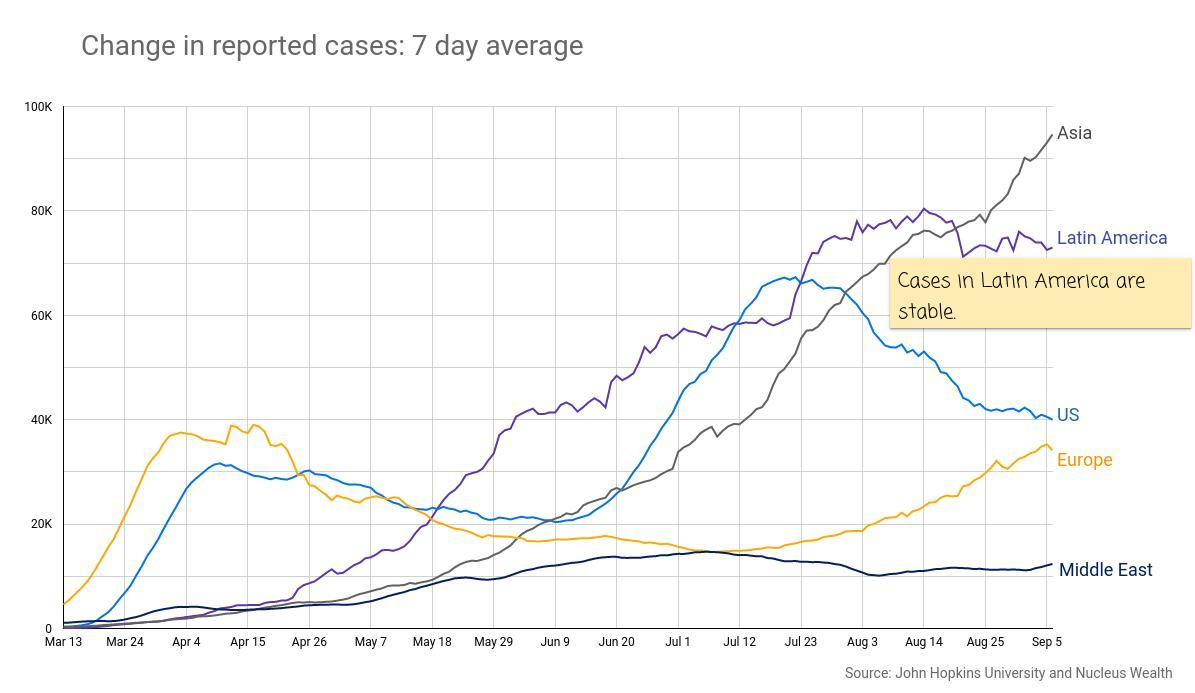Which three regions have less than 50k cases on September 5th?
Answer the question with a short phrase. US, Europe, Middle East When comparing Europe and US, who had a higher number of reported cases in  April 26-May27? US Which region has the highest number of cases reported, in the period March 24-April 26? Europe Which region has the lowest number of cases in the period June 9 to June 20? Middle East Which region has highest number of cases in the period August 3-August 14? Latin America How many regions are plotted on the graph? 5 Which region has the highest number of cases in the period June 9-June 20? Latin America Which region had the highest number of cases on March 13th? Europe Which are the two regions that crossed 70k cases in the period Aug25-Sep5? Asia, Latin America Which region has the highest number of cases in the period July 12-July 23? US When comparing Europe and Middle East, which region had higher number of reported cases in July 12-July 23? Europe What was the number of cases reported in US, on April 26? 30000 Which color is used to represent Europe on the line graph - red yellow Blue or green? Yellow 